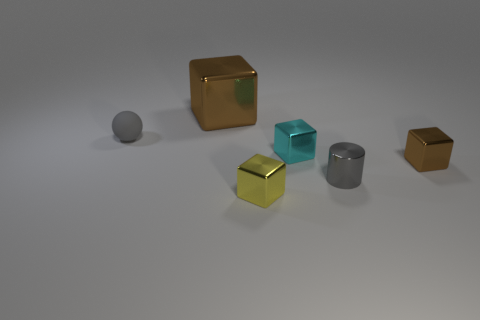Is there any other thing that has the same material as the tiny yellow object?
Make the answer very short. Yes. There is a object on the left side of the block on the left side of the small object that is in front of the gray metallic object; what is its color?
Ensure brevity in your answer.  Gray. Is there any other thing of the same color as the shiny cylinder?
Ensure brevity in your answer.  Yes. There is another thing that is the same color as the matte object; what shape is it?
Make the answer very short. Cylinder. How big is the brown metallic block that is behind the cyan metallic thing?
Provide a succinct answer. Large. What shape is the brown thing that is the same size as the rubber sphere?
Your answer should be very brief. Cube. Does the brown cube in front of the small gray rubber ball have the same material as the tiny gray object that is on the left side of the small cyan shiny cube?
Your response must be concise. No. What material is the object that is behind the gray object that is behind the tiny brown cube?
Offer a terse response. Metal. There is a brown metallic block that is to the right of the small shiny object behind the brown thing in front of the big metal object; how big is it?
Your response must be concise. Small. Do the yellow metallic block and the gray sphere have the same size?
Offer a very short reply. Yes. 